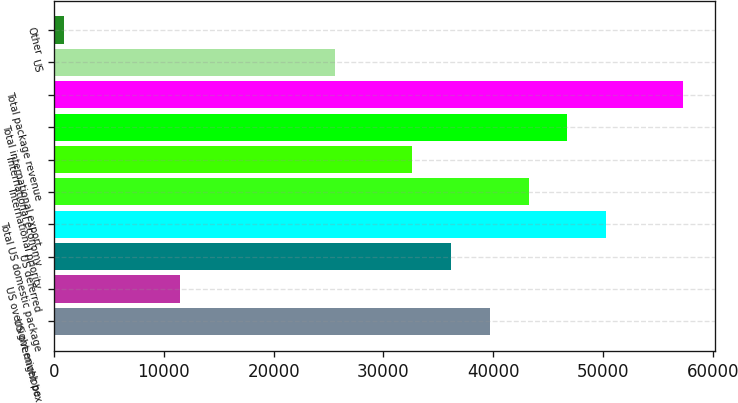Convert chart. <chart><loc_0><loc_0><loc_500><loc_500><bar_chart><fcel>US overnight box<fcel>US overnight envelope<fcel>US deferred<fcel>Total US domestic package<fcel>International priority<fcel>International economy<fcel>Total international export<fcel>Total package revenue<fcel>US<fcel>Other<nl><fcel>39697.7<fcel>11492.1<fcel>36172<fcel>50274.8<fcel>43223.4<fcel>32646.3<fcel>46749.1<fcel>57326.2<fcel>25594.9<fcel>915<nl></chart> 